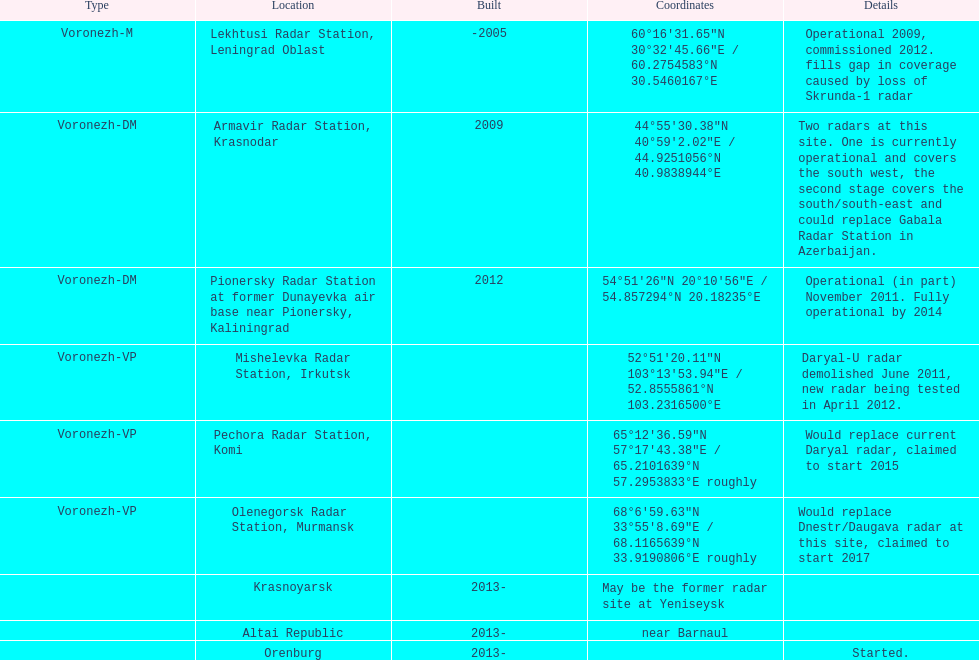Which site has the most radars? Armavir Radar Station, Krasnodar. 